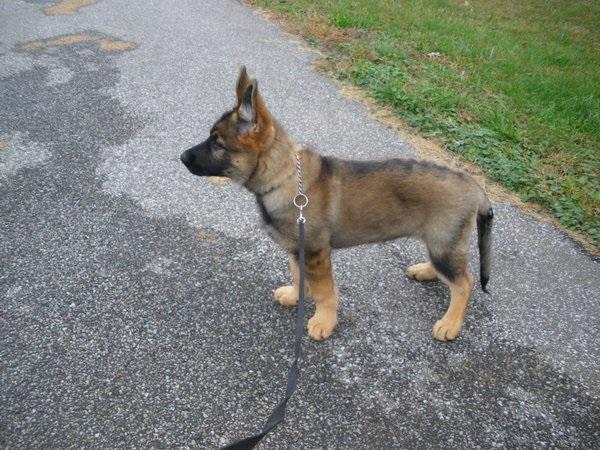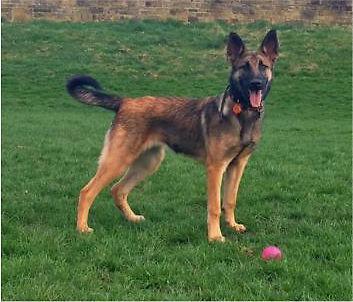The first image is the image on the left, the second image is the image on the right. Assess this claim about the two images: "One dog is on a leash, while a second dog is not, but is wearing a collar and is standing on grass with its tongue out and tail outstretched.". Correct or not? Answer yes or no. Yes. The first image is the image on the left, the second image is the image on the right. Examine the images to the left and right. Is the description "A german shepherd wearing a collar without a leash stands on the grass on all fours, with its tail nearly parallel to the ground." accurate? Answer yes or no. Yes. 